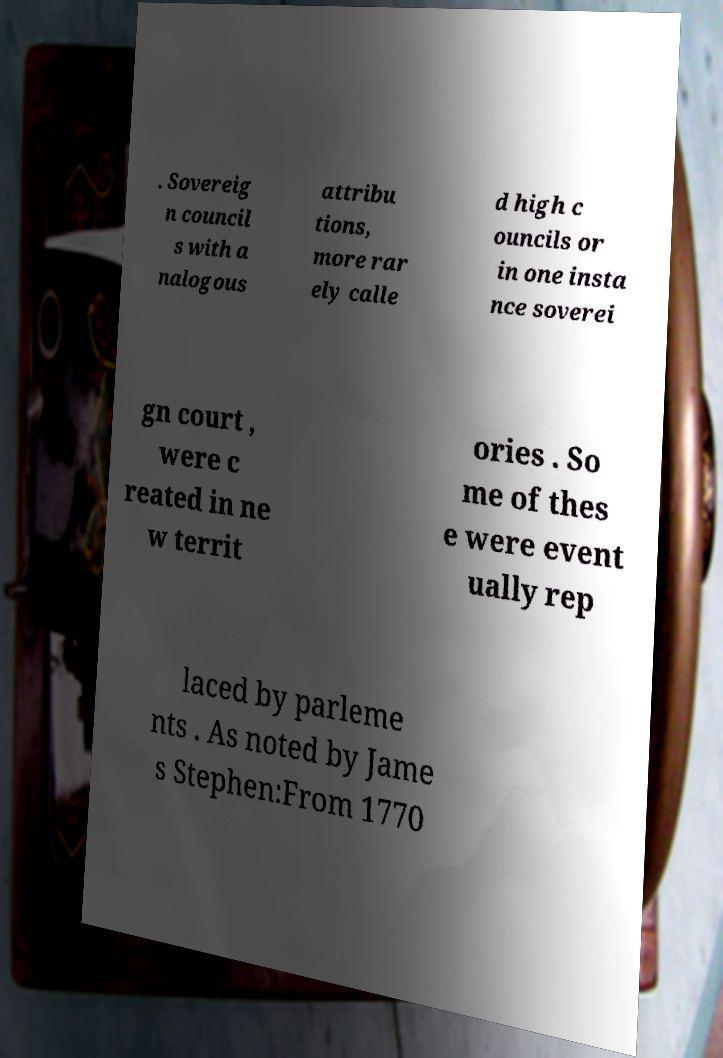Please identify and transcribe the text found in this image. . Sovereig n council s with a nalogous attribu tions, more rar ely calle d high c ouncils or in one insta nce soverei gn court , were c reated in ne w territ ories . So me of thes e were event ually rep laced by parleme nts . As noted by Jame s Stephen:From 1770 